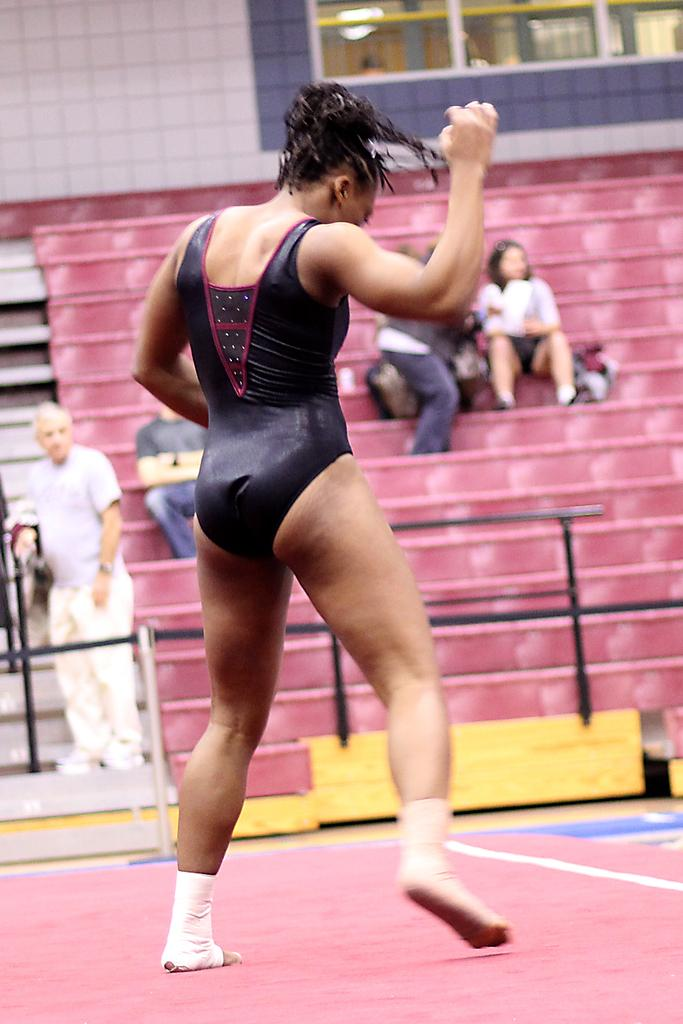How many people are present in the image? There are five people in the image, two standing and three sitting on stairs. What are the people in the image wearing? The two persons standing are wearing clothes. Where are the three persons sitting in the image? The three persons are sitting on stairs in the image. What can be seen at the top of the image? There is a wall at the top of the image. What type of weather can be seen in the image? The image does not provide any information about the weather, as it only shows people and a wall. How many dimes are visible on the wall in the image? There are no dimes visible on the wall in the image. 